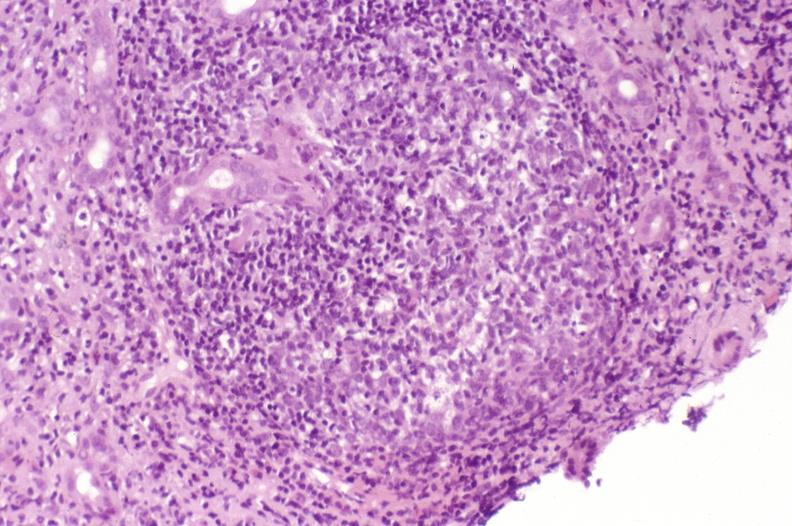does fixed tissue show recurrent hepatitis c virus?
Answer the question using a single word or phrase. No 